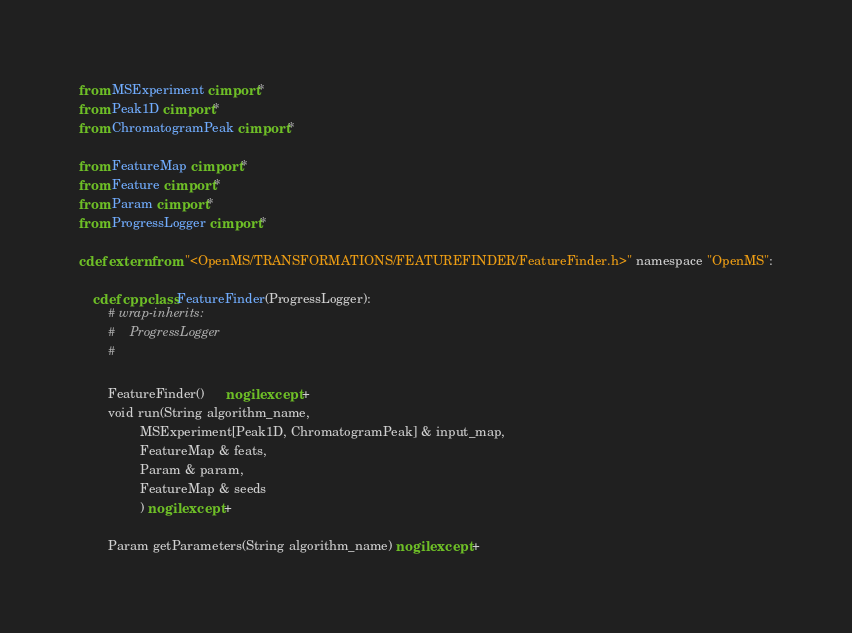<code> <loc_0><loc_0><loc_500><loc_500><_Cython_>from MSExperiment cimport *
from Peak1D cimport *
from ChromatogramPeak cimport *

from FeatureMap cimport *
from Feature cimport *
from Param cimport *
from ProgressLogger cimport *

cdef extern from "<OpenMS/TRANSFORMATIONS/FEATUREFINDER/FeatureFinder.h>" namespace "OpenMS":

    cdef cppclass FeatureFinder(ProgressLogger):
        # wrap-inherits:
        #    ProgressLogger
        #

        FeatureFinder()      nogil except +
        void run(String algorithm_name,
                 MSExperiment[Peak1D, ChromatogramPeak] & input_map,
                 FeatureMap & feats,
                 Param & param,
                 FeatureMap & seeds
                 ) nogil except +

        Param getParameters(String algorithm_name) nogil except +
</code> 